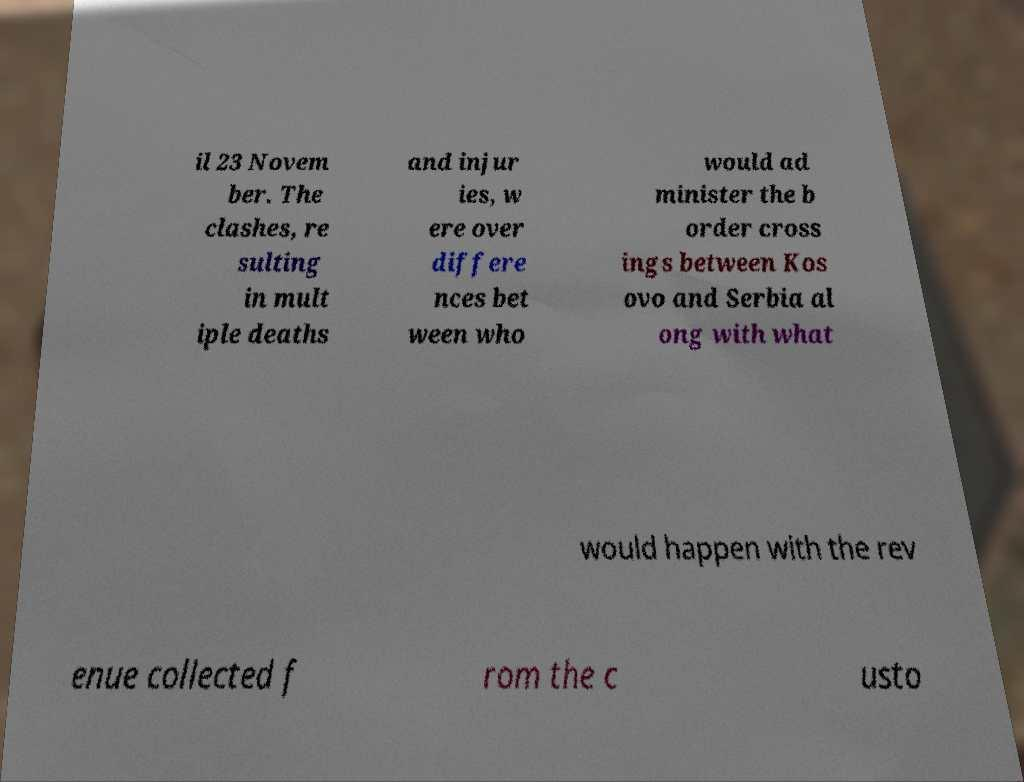Could you extract and type out the text from this image? il 23 Novem ber. The clashes, re sulting in mult iple deaths and injur ies, w ere over differe nces bet ween who would ad minister the b order cross ings between Kos ovo and Serbia al ong with what would happen with the rev enue collected f rom the c usto 